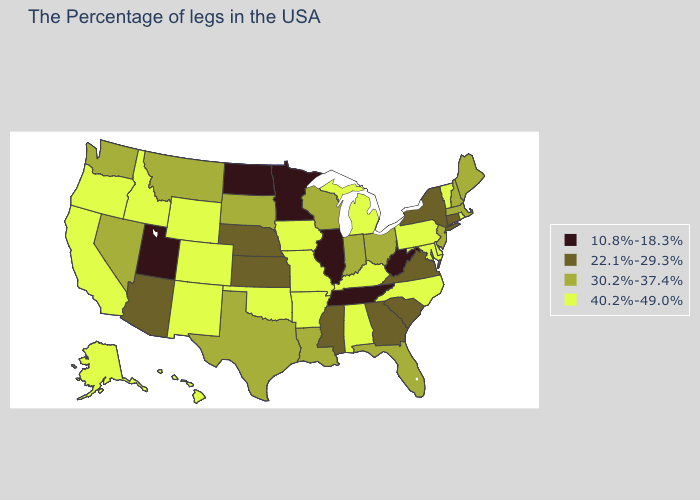Name the states that have a value in the range 40.2%-49.0%?
Short answer required. Rhode Island, Vermont, Delaware, Maryland, Pennsylvania, North Carolina, Michigan, Kentucky, Alabama, Missouri, Arkansas, Iowa, Oklahoma, Wyoming, Colorado, New Mexico, Idaho, California, Oregon, Alaska, Hawaii. What is the value of Oregon?
Be succinct. 40.2%-49.0%. What is the value of Idaho?
Write a very short answer. 40.2%-49.0%. Name the states that have a value in the range 40.2%-49.0%?
Keep it brief. Rhode Island, Vermont, Delaware, Maryland, Pennsylvania, North Carolina, Michigan, Kentucky, Alabama, Missouri, Arkansas, Iowa, Oklahoma, Wyoming, Colorado, New Mexico, Idaho, California, Oregon, Alaska, Hawaii. Does the first symbol in the legend represent the smallest category?
Write a very short answer. Yes. Name the states that have a value in the range 40.2%-49.0%?
Keep it brief. Rhode Island, Vermont, Delaware, Maryland, Pennsylvania, North Carolina, Michigan, Kentucky, Alabama, Missouri, Arkansas, Iowa, Oklahoma, Wyoming, Colorado, New Mexico, Idaho, California, Oregon, Alaska, Hawaii. Name the states that have a value in the range 40.2%-49.0%?
Keep it brief. Rhode Island, Vermont, Delaware, Maryland, Pennsylvania, North Carolina, Michigan, Kentucky, Alabama, Missouri, Arkansas, Iowa, Oklahoma, Wyoming, Colorado, New Mexico, Idaho, California, Oregon, Alaska, Hawaii. Among the states that border Washington , which have the lowest value?
Short answer required. Idaho, Oregon. What is the value of Virginia?
Answer briefly. 22.1%-29.3%. Does Maine have a higher value than Kentucky?
Answer briefly. No. What is the value of Washington?
Answer briefly. 30.2%-37.4%. Does New Mexico have the highest value in the USA?
Quick response, please. Yes. How many symbols are there in the legend?
Answer briefly. 4. What is the highest value in states that border Indiana?
Answer briefly. 40.2%-49.0%. Among the states that border Colorado , does Utah have the lowest value?
Write a very short answer. Yes. 